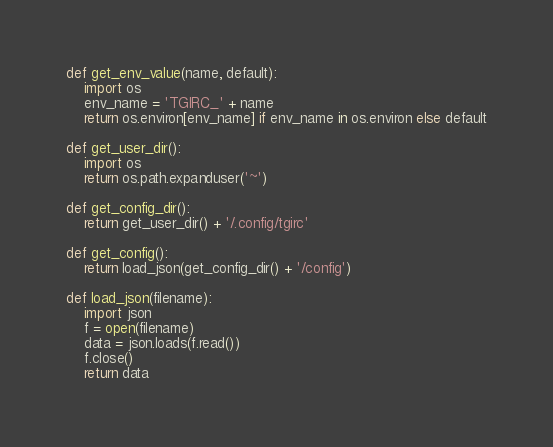Convert code to text. <code><loc_0><loc_0><loc_500><loc_500><_Python_>def get_env_value(name, default):
    import os
    env_name = 'TGIRC_' + name
    return os.environ[env_name] if env_name in os.environ else default

def get_user_dir():
    import os
    return os.path.expanduser('~')

def get_config_dir():
    return get_user_dir() + '/.config/tgirc'

def get_config():
    return load_json(get_config_dir() + '/config')

def load_json(filename):
    import json
    f = open(filename)
    data = json.loads(f.read())
    f.close()
    return data
</code> 